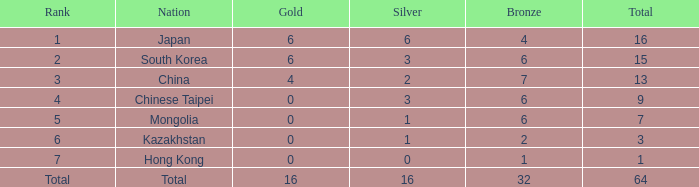Which silver is associated with china's nation and has a bronze less than 7? None. 